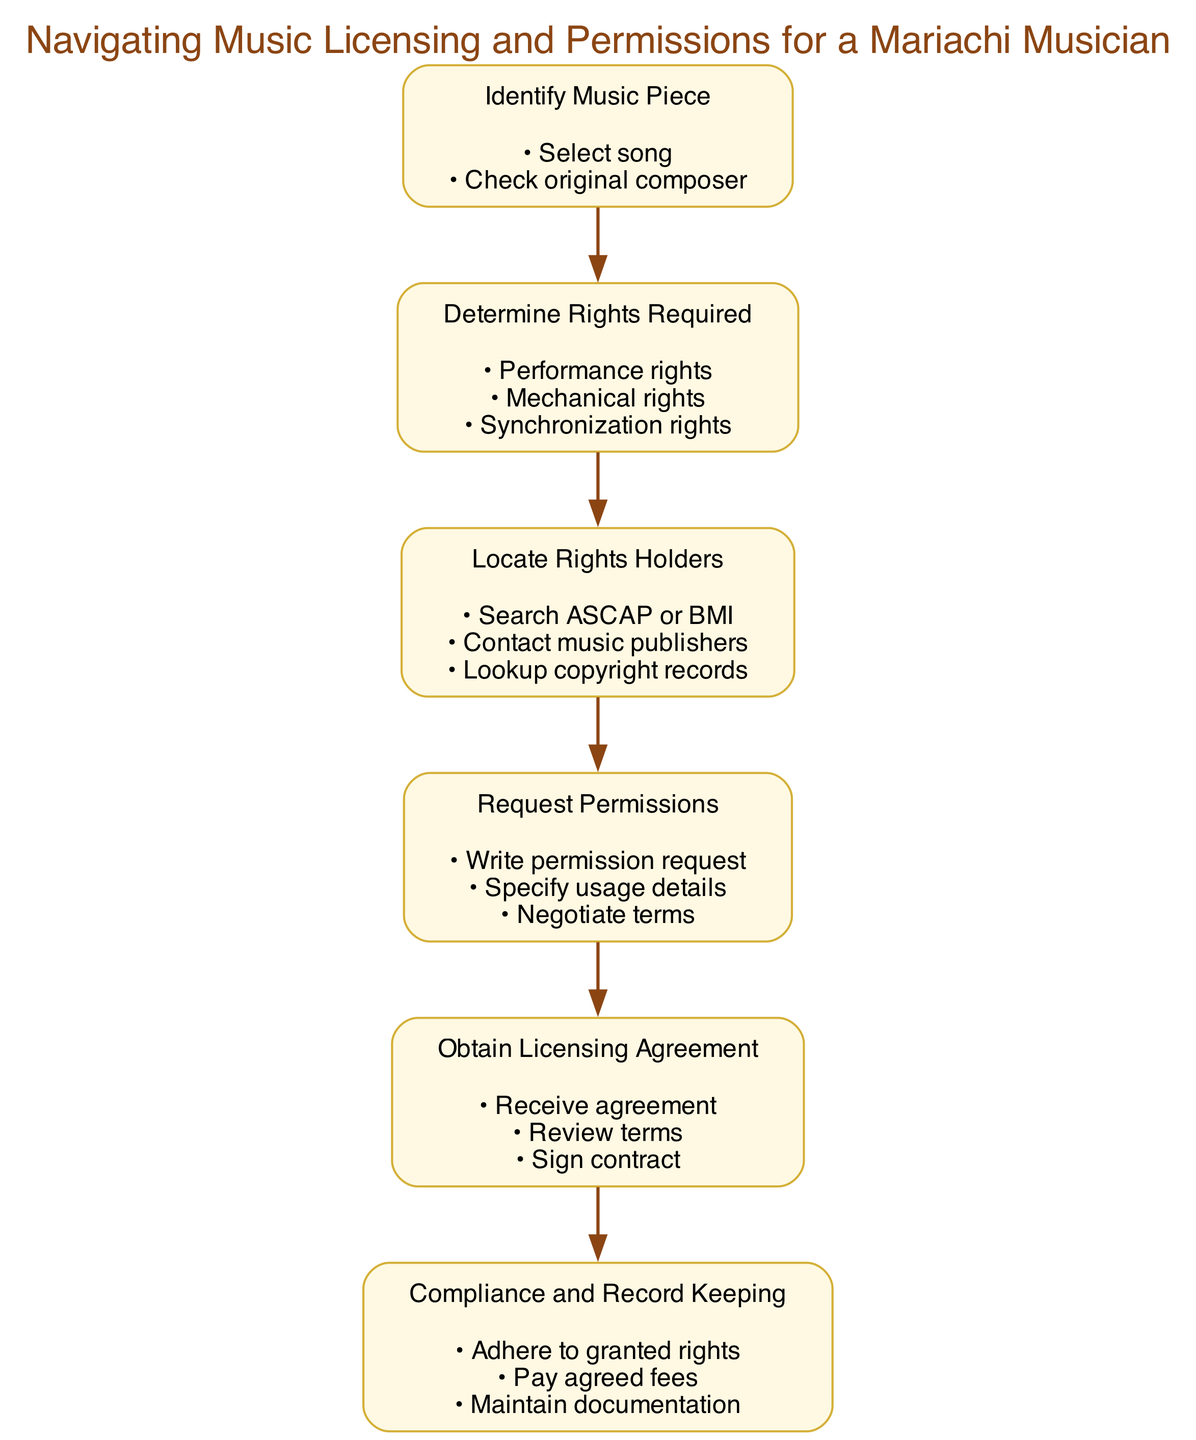What is the first step in the flowchart? The first step is identified by the lowest numbered node, which is "Identify Music Piece." This is the starting point that sets the stage for the entire licensing process.
Answer: Identify Music Piece How many actions are listed under "Request Permissions"? To find the number of actions under this node, we count the bullet points in the actions section beneath "Request Permissions." There are three actions listed: Write permission request, Specify usage details, Negotiate terms.
Answer: 3 What type of rights do you need to determine in step 2? The rights mentioned in step 2 are categorized as types needed for intended music use, specifically "Performance rights," "Mechanical rights," and "Synchronization rights." All three types need to be determined.
Answer: Performance rights, Mechanical rights, Synchronization rights What step follows "Locate Rights Holders"? By analyzing the connections (edges) between the nodes, we can see that "Request Permissions" is the next step that follows "Locate Rights Holders," which is the fourth node in the sequence.
Answer: Request Permissions Which step discusses compliance and record-keeping? The final (last) node in the flowchart outlines the requirement for compliance and maintaining records. This node is labeled "Compliance and Record Keeping." It emphasizes the importance of adhering to agreed terms after licensing.
Answer: Compliance and Record Keeping What is the relationship between the "Obtain Licensing Agreement" and "Request Permissions" steps? The relationship is sequential; "Obtain Licensing Agreement" directly follows "Request Permissions" in the diagram, indicating that after requesting permissions, the next logical step is to secure the licensing agreement based on those permissions.
Answer: Sequential relationship How many total steps are in the diagram? To find the total number of steps, we simply count the numbered steps in the flowchart. There are six distinct steps in total that detail the music licensing process specifically for a mariachi musician.
Answer: 6 What is required after receiving the licensing agreement? After receiving the agreement, the step instructs you to "Review terms" as part of ensuring understanding and compliance before any further action. This indicates the careful consideration necessary post-agreement.
Answer: Review terms 